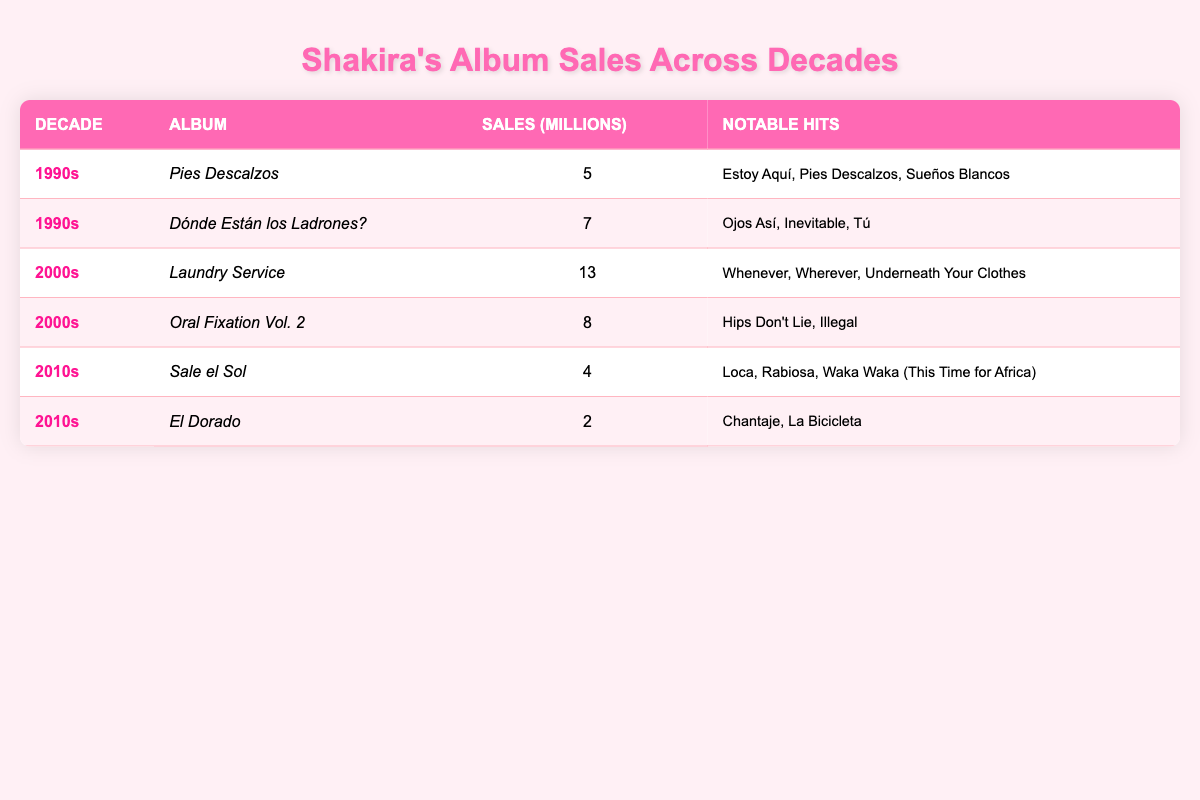What was the highest selling album of Shakira? The table shows "Laundry Service" from the 2000s with sales of 13 million, which is the highest compared to all other albums listed.
Answer: Laundry Service Which decade had the most albums listed in the table? There are two albums from the 1990s, two from the 2000s, and two from the 2010s, making each decade have the same number of albums listed. Thus, there's no single decade with more albums.
Answer: No single decade What is the total sales of Shakira's albums in the 1990s? The sales for "Pies Descalzos" and "Dónde Están los Ladrones?" in the 1990s are 5 million and 7 million respectively. Adding these gives a total of 5 + 7 = 12 million.
Answer: 12 million Which album sold more, "El Dorado" or "Pies Descalzos"? "El Dorado" sold 2 million, while "Pies Descalzos" sold 5 million. Comparing these values, Pies Descalzos is higher.
Answer: Pies Descalzos Is it true that every album listed from the 2000s sold over 8 million copies? "Laundry Service" sold 13 million, which is above 8 million, and "Oral Fixation Vol. 2" sold 8 million exactly. Thus, both albums meet the sales criteria.
Answer: Yes 